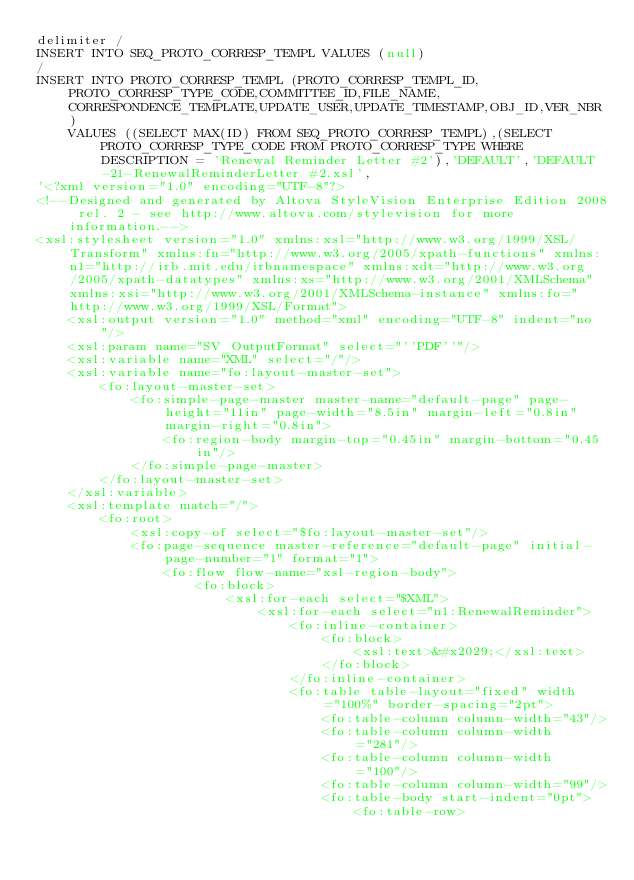<code> <loc_0><loc_0><loc_500><loc_500><_SQL_>delimiter /
INSERT INTO SEQ_PROTO_CORRESP_TEMPL VALUES (null)
/
INSERT INTO PROTO_CORRESP_TEMPL (PROTO_CORRESP_TEMPL_ID,PROTO_CORRESP_TYPE_CODE,COMMITTEE_ID,FILE_NAME,CORRESPONDENCE_TEMPLATE,UPDATE_USER,UPDATE_TIMESTAMP,OBJ_ID,VER_NBR)
    VALUES ((SELECT MAX(ID) FROM SEQ_PROTO_CORRESP_TEMPL),(SELECT PROTO_CORRESP_TYPE_CODE FROM PROTO_CORRESP_TYPE WHERE DESCRIPTION = 'Renewal Reminder Letter #2'),'DEFAULT','DEFAULT-21-RenewalReminderLetter #2.xsl',
'<?xml version="1.0" encoding="UTF-8"?>
<!--Designed and generated by Altova StyleVision Enterprise Edition 2008 rel. 2 - see http://www.altova.com/stylevision for more information.-->
<xsl:stylesheet version="1.0" xmlns:xsl="http://www.w3.org/1999/XSL/Transform" xmlns:fn="http://www.w3.org/2005/xpath-functions" xmlns:n1="http://irb.mit.edu/irbnamespace" xmlns:xdt="http://www.w3.org/2005/xpath-datatypes" xmlns:xs="http://www.w3.org/2001/XMLSchema" xmlns:xsi="http://www.w3.org/2001/XMLSchema-instance" xmlns:fo="http://www.w3.org/1999/XSL/Format">
    <xsl:output version="1.0" method="xml" encoding="UTF-8" indent="no"/>
    <xsl:param name="SV_OutputFormat" select="''PDF''"/>
    <xsl:variable name="XML" select="/"/>
    <xsl:variable name="fo:layout-master-set">
        <fo:layout-master-set>
            <fo:simple-page-master master-name="default-page" page-height="11in" page-width="8.5in" margin-left="0.8in" margin-right="0.8in">
                <fo:region-body margin-top="0.45in" margin-bottom="0.45in"/>
            </fo:simple-page-master>
        </fo:layout-master-set>
    </xsl:variable>
    <xsl:template match="/">
        <fo:root>
            <xsl:copy-of select="$fo:layout-master-set"/>
            <fo:page-sequence master-reference="default-page" initial-page-number="1" format="1">
                <fo:flow flow-name="xsl-region-body">
                    <fo:block>
                        <xsl:for-each select="$XML">
                            <xsl:for-each select="n1:RenewalReminder">
                                <fo:inline-container>
                                    <fo:block>
                                        <xsl:text>&#x2029;</xsl:text>
                                    </fo:block>
                                </fo:inline-container>
                                <fo:table table-layout="fixed" width="100%" border-spacing="2pt">
                                    <fo:table-column column-width="43"/>
                                    <fo:table-column column-width="281"/>
                                    <fo:table-column column-width="100"/>
                                    <fo:table-column column-width="99"/>
                                    <fo:table-body start-indent="0pt">
                                        <fo:table-row></code> 